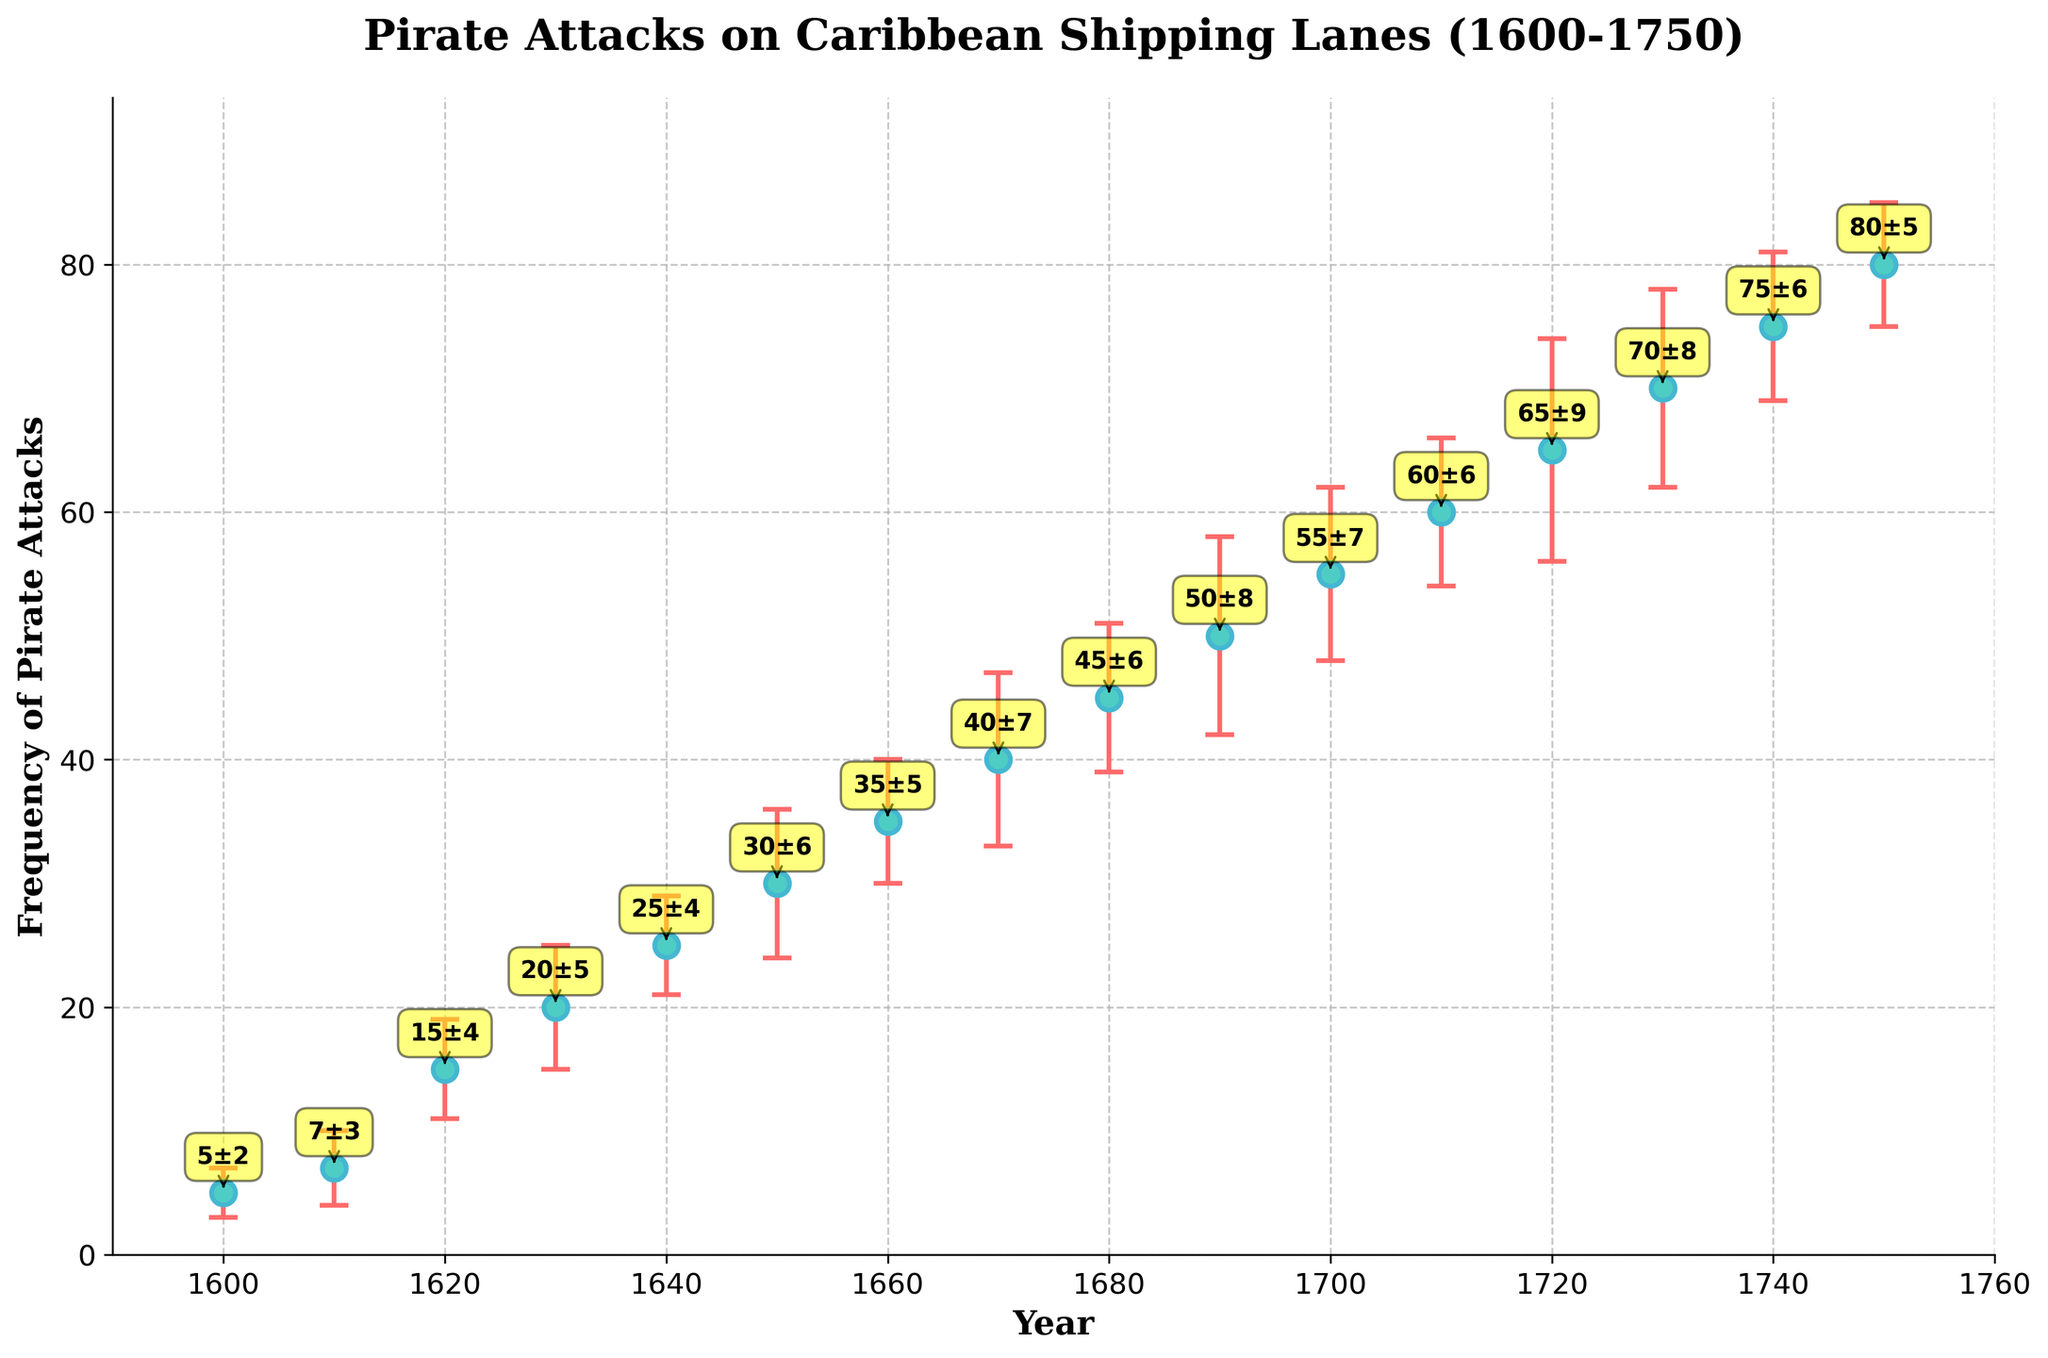What is the title of the figure? The title of the figure is written at the top of the chart. It states what the figure is about.
Answer: Pirate Attacks on Caribbean Shipping Lanes (1600-1750) What is the frequency of pirate attacks in the year 1650? To find the frequency of pirate attacks in 1650, look at the data point that corresponds to the year 1650 on the x-axis.
Answer: 30 Which year recorded the highest frequency of pirate attacks? To determine the highest frequency, find the data point with the maximum y-value.
Answer: 1750 What is the error value for the frequency of pirate attacks in 1700? Check the vertical error bar on the data point for the year 1700 to see the error value.
Answer: 7 How many data points are plotted on the graph? Count the total number of markers that represent data points on the scatter plot.
Answer: 16 By how much did the frequency of pirate attacks increase between 1600 and 1650? Subtract the frequency value at 1600 from the frequency value at 1650. (30-5)
Answer: 25 What is the average frequency of pirate attacks from 1600 to 1700? Add the frequency values for the years 1600 to 1700 and divide by the number of data points involved. (5+7+15+20+25+30+35+40+45+50+55)/11 = 29.5
Answer: 29.5 Compare the error margins for the years 1660 and 1680. Which one is larger? Check the error bars for the years 1660 and 1680 and see which error bar is longer.
Answer: 1680 What does the error bar represent in this figure? Error bars indicate the discrepancies in historical record accuracy for each data point.
Answer: Discrepancies in historical record accuracy Which decade saw the least discrepancy in historical record accuracy? Check all the error bars and find the decade where the error bars are smallest. Compare the error bar heights.
Answer: 1740s 